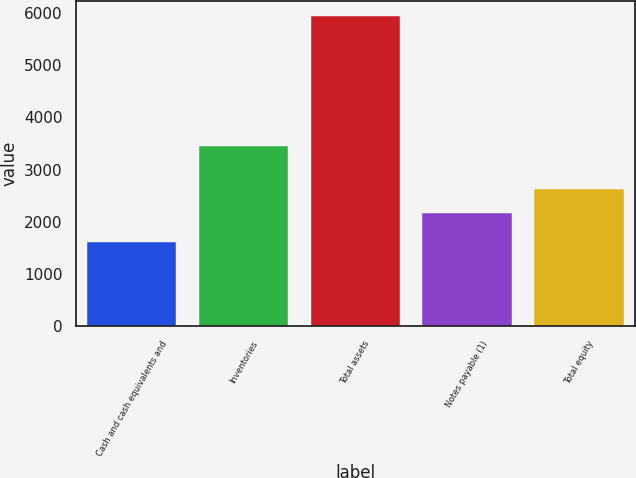Convert chart. <chart><loc_0><loc_0><loc_500><loc_500><bar_chart><fcel>Cash and cash equivalents and<fcel>Inventories<fcel>Total assets<fcel>Notes payable (1)<fcel>Total equity<nl><fcel>1607<fcel>3449<fcel>5938.6<fcel>2171.8<fcel>2622.9<nl></chart> 